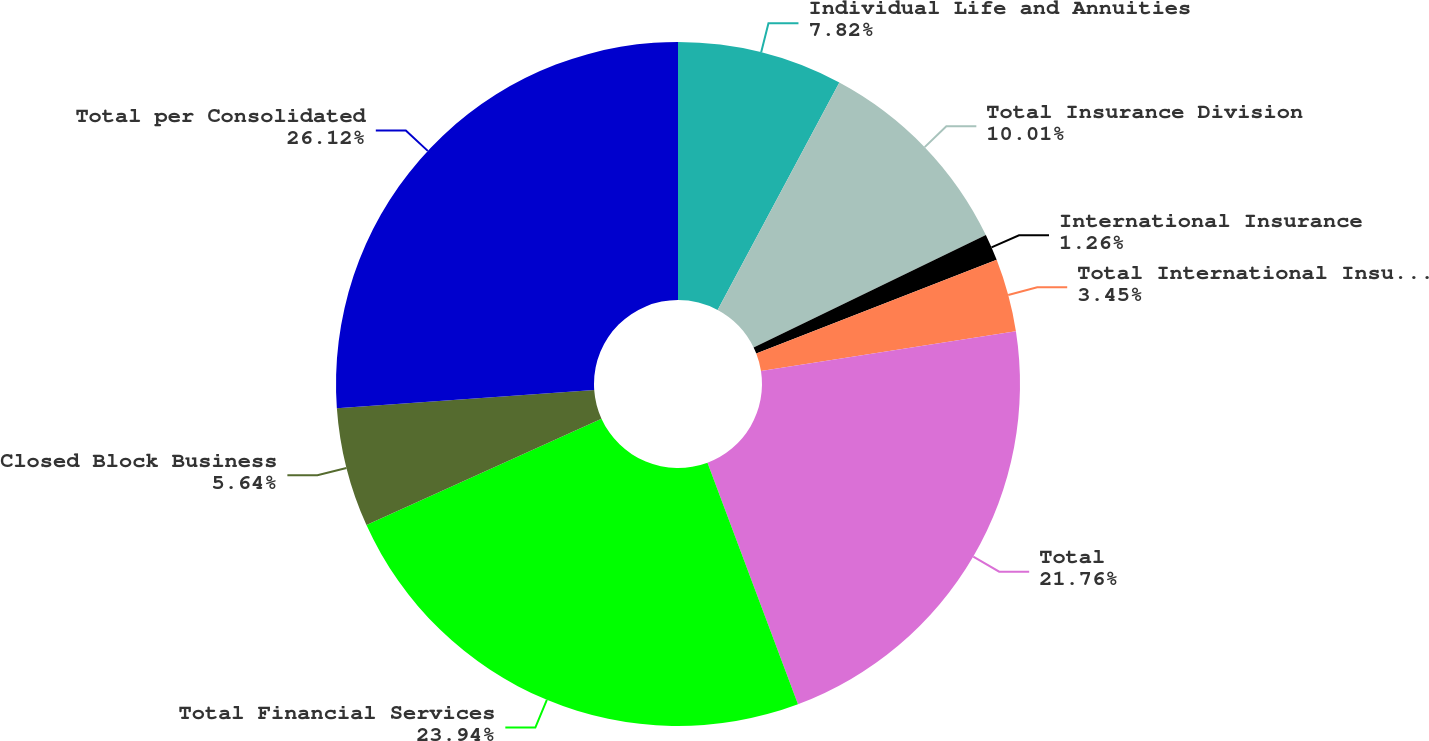<chart> <loc_0><loc_0><loc_500><loc_500><pie_chart><fcel>Individual Life and Annuities<fcel>Total Insurance Division<fcel>International Insurance<fcel>Total International Insurance<fcel>Total<fcel>Total Financial Services<fcel>Closed Block Business<fcel>Total per Consolidated<nl><fcel>7.82%<fcel>10.01%<fcel>1.26%<fcel>3.45%<fcel>21.76%<fcel>23.94%<fcel>5.64%<fcel>26.13%<nl></chart> 